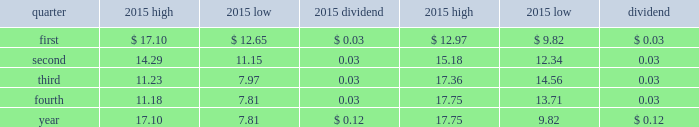Part ii item 5 .
Market for registrant 2019s common equity , related stockholder matters and issuer purchases of equity securities .
The company 2019s common stock is listed on the new york stock exchange where it trades under the symbol aa .
The company 2019s quarterly high and low trading stock prices and dividends per common share for 2015 and 2014 are shown below. .
The number of holders of record of common stock was approximately 10101 as of february 11 , 2016. .
Considering the fourth quarter , what is the variation between the low trading stock prices during 2014 and 2015? 
Rationale: it is the difference between those two prices during 2015 and 2014 .
Computations: (13.71 - 7.81)
Answer: 5.9. 